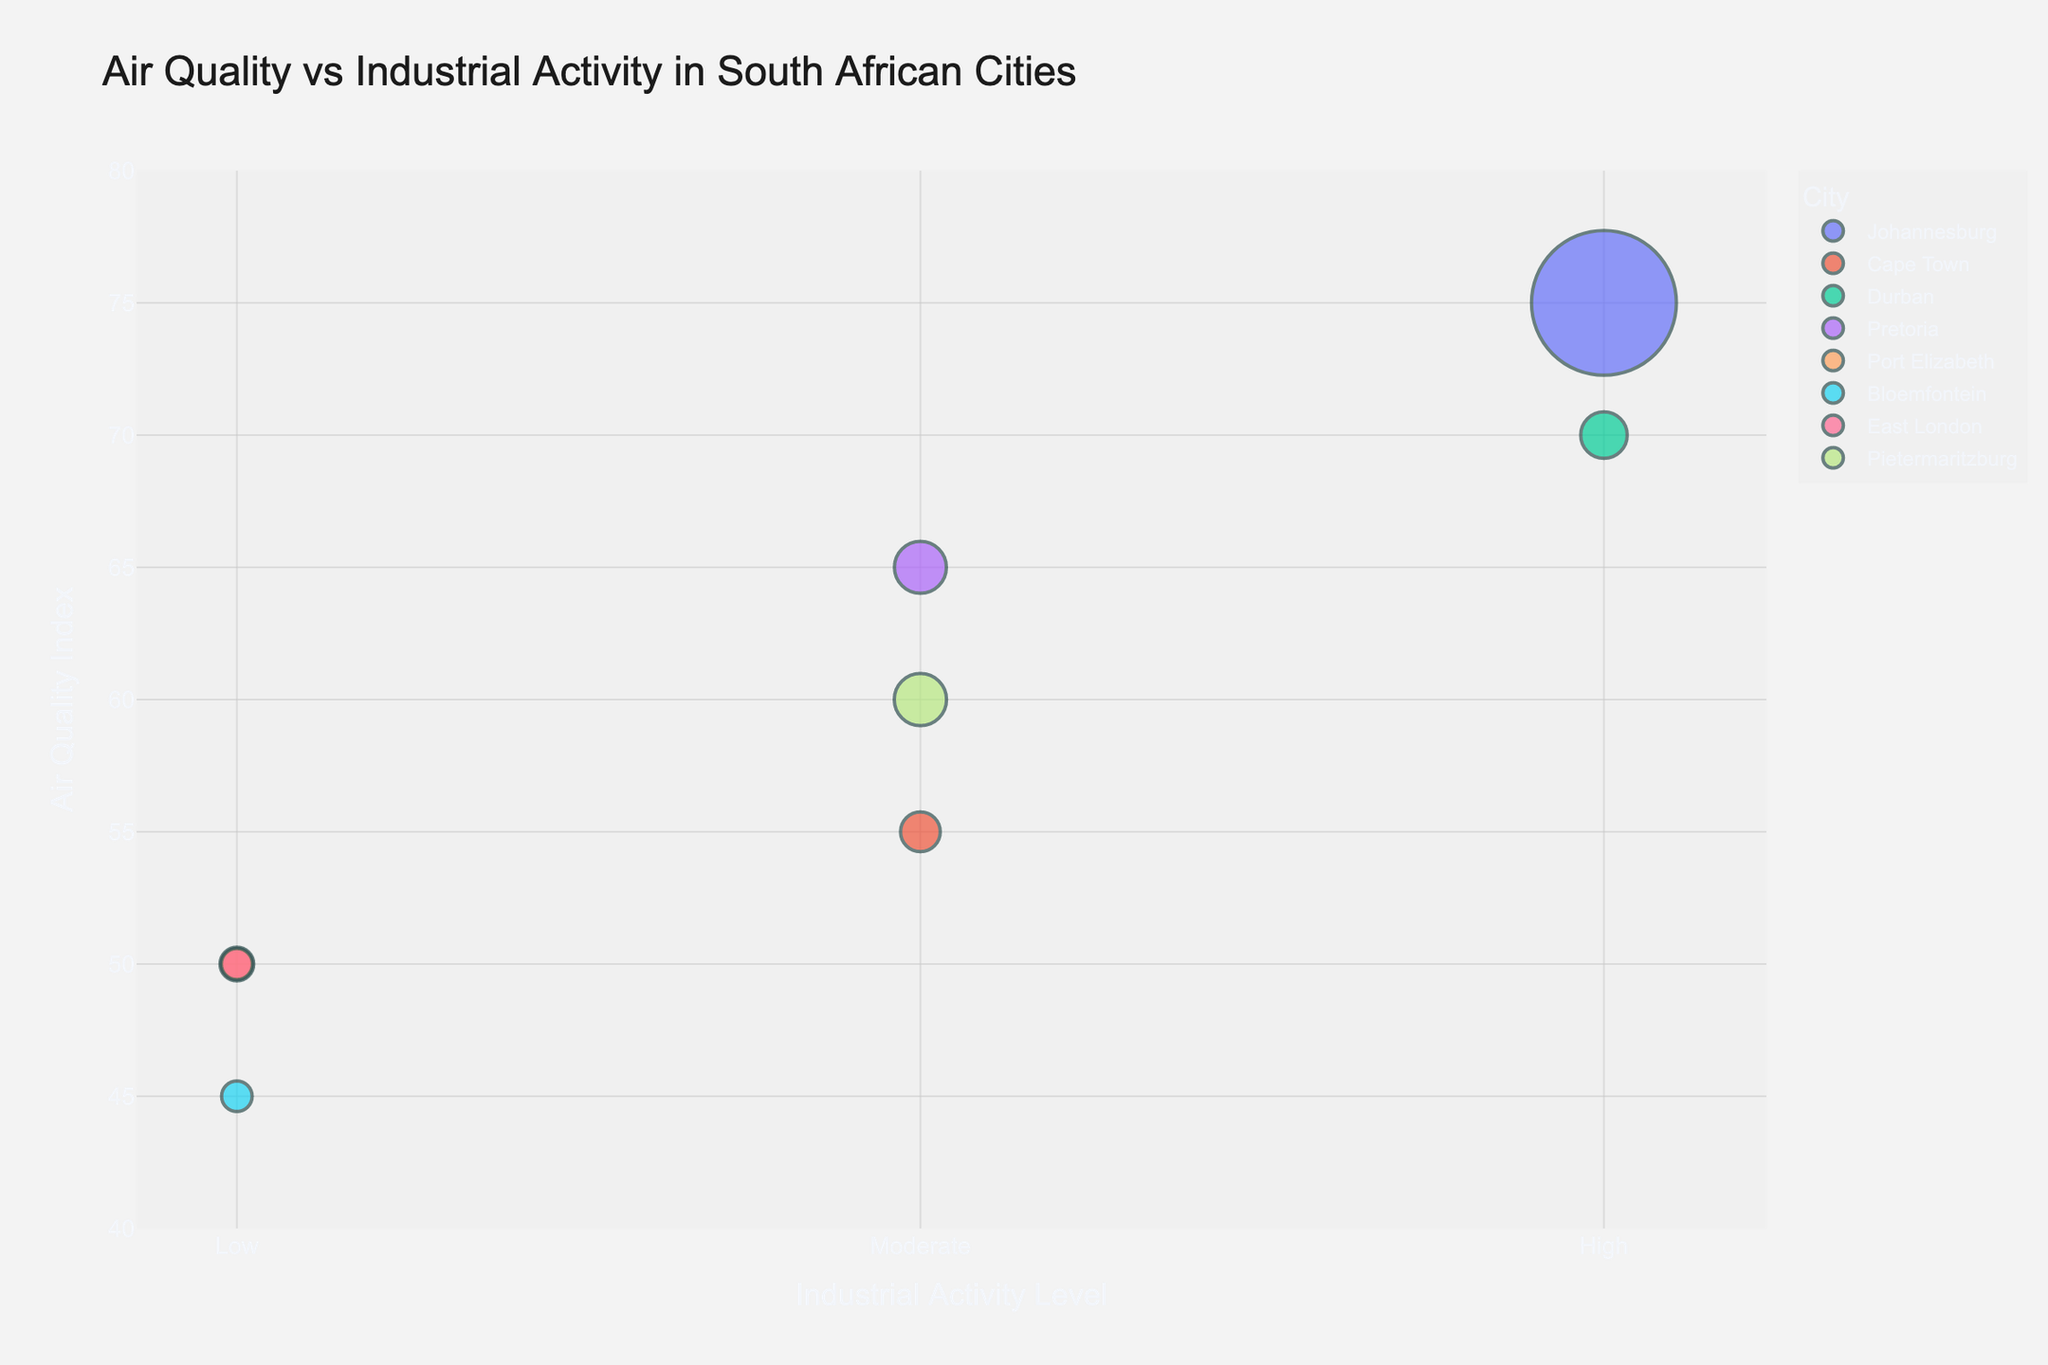What is the title of the chart? The title is displayed prominently at the top of the chart. It indicates what the chart is about, providing immediate context.
Answer: Air Quality vs Industrial Activity in South African Cities How many cities are represented on the chart? Each bubble on the chart represents a city. By counting the bubbles, you can determine the number of cities.
Answer: 8 Which city has the highest Air Quality Index? The Air Quality Index is displayed on the y-axis. By looking at which bubble is furthest up on the y-axis, you can determine the city with the highest index.
Answer: Johannesburg What is the relationship between industrial activity and air quality in Johannesburg and Durban? Both Johannesburg and Durban are categorized under "High" for industrial activity. By comparing their positions on the y-axis, we can see if higher industrial activity correlates with higher or lower Air Quality Index within these cities.
Answer: Both have high industrial activity and relatively high Air Quality Indexes (Johannesburg: 75, Durban: 70) Which city has the largest population, and how is it represented on the chart? The size of the bubbles represents the population. The largest bubble will indicate the city with the largest population.
Answer: Johannesburg How does Pretoria's air quality compare to Cape Town's? The Air Quality Index is on the y-axis, and you can compare their positions on this axis.
Answer: Pretoria has a higher Air Quality Index (65) compared to Cape Town (55) What is the average Air Quality Index for cities with moderate industrial activity? Cities with moderate industrial activity are Cape Town, Pretoria, and Pietermaritzburg. By averaging their Air Quality Index values: (55 + 65 + 60) / 3 = 180 / 3
Answer: 60 Which city has the lowest Air Quality Index, and what is its industrial activity level? The lowest point on the y-axis corresponds to the lowest Air Quality Index. By identifying this bubble and checking the corresponding x-axis value, we can determine the industrial activity level.
Answer: Bloemfontein, Low Compare the Air Quality Index of Port Elizabeth and East London. Which city has a better air quality and how significant is the difference? Both cities are positioned on the y-axis. By noting their indexes, you can subtract one from the other to find the difference.
Answer: Both have an Air Quality Index of 50. There is no difference Are there any anomalies or unexpected patterns in the chart regarding industrial activity levels and air quality? By observing the bubbles and their distribution across different industrial activity levels, any deviations from the normal expectations of higher activity correlating with lower air quality can be identified.
Answer: Despite having high industrial activity, Johannesburg has worse air quality than Durban, but the difference between low and moderate levels doesn't indicate a clear pattern 